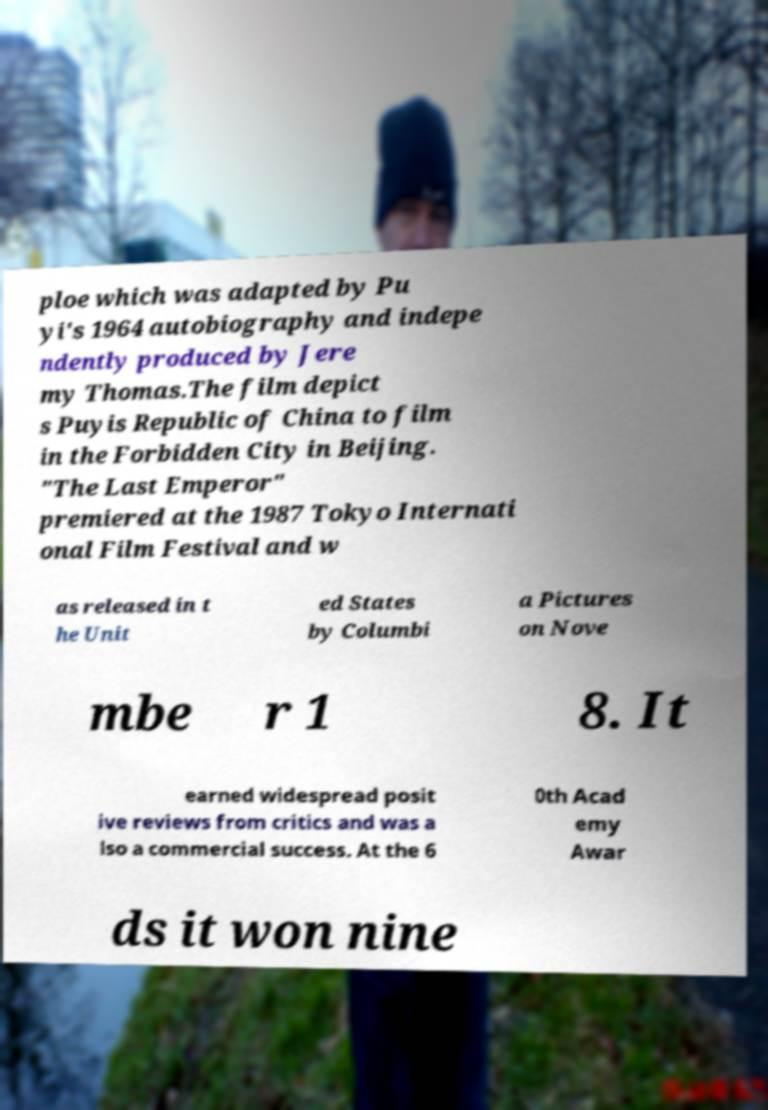Can you accurately transcribe the text from the provided image for me? ploe which was adapted by Pu yi's 1964 autobiography and indepe ndently produced by Jere my Thomas.The film depict s Puyis Republic of China to film in the Forbidden City in Beijing. "The Last Emperor" premiered at the 1987 Tokyo Internati onal Film Festival and w as released in t he Unit ed States by Columbi a Pictures on Nove mbe r 1 8. It earned widespread posit ive reviews from critics and was a lso a commercial success. At the 6 0th Acad emy Awar ds it won nine 